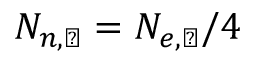Convert formula to latex. <formula><loc_0><loc_0><loc_500><loc_500>N _ { n , \ast r o s u n } = N _ { e , \ast r o s u n } / 4</formula> 